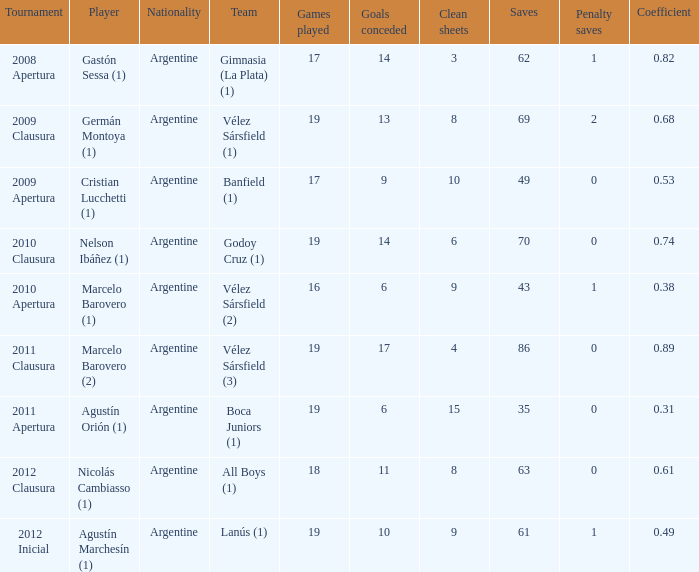What is the nationality of the 2012 clausura  tournament? Argentine. Would you be able to parse every entry in this table? {'header': ['Tournament', 'Player', 'Nationality', 'Team', 'Games played', 'Goals conceded', 'Clean sheets', 'Saves', 'Penalty saves', 'Coefficient'], 'rows': [['2008 Apertura', 'Gastón Sessa (1)', 'Argentine', 'Gimnasia (La Plata) (1)', '17', '14', '3', '62', '1', '0.82'], ['2009 Clausura', 'Germán Montoya (1)', 'Argentine', 'Vélez Sársfield (1)', '19', '13', '8', '69', '2', '0.68'], ['2009 Apertura', 'Cristian Lucchetti (1)', 'Argentine', 'Banfield (1)', '17', '9', '10', '49', '0', '0.53'], ['2010 Clausura', 'Nelson Ibáñez (1)', 'Argentine', 'Godoy Cruz (1)', '19', '14', '6', '70', '0', '0.74'], ['2010 Apertura', 'Marcelo Barovero (1)', 'Argentine', 'Vélez Sársfield (2)', '16', '6', '9', '43', '1', '0.38'], ['2011 Clausura', 'Marcelo Barovero (2)', 'Argentine', 'Vélez Sársfield (3)', '19', '17', '4', '86', '0', '0.89'], ['2011 Apertura', 'Agustín Orión (1)', 'Argentine', 'Boca Juniors (1)', '19', '6', '15', '35', '0', '0.31'], ['2012 Clausura', 'Nicolás Cambiasso (1)', 'Argentine', 'All Boys (1)', '18', '11', '8', '63', '0', '0.61'], ['2012 Inicial', 'Agustín Marchesín (1)', 'Argentine', 'Lanús (1)', '19', '10', '9', '61', '1', '0.49']]} 